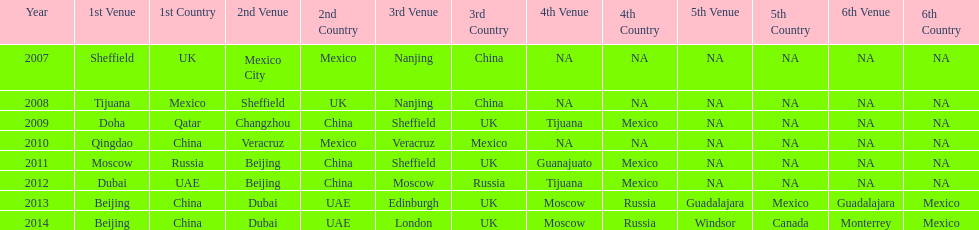In what year was the 3rd venue the same as 2011's 1st venue? 2012. 